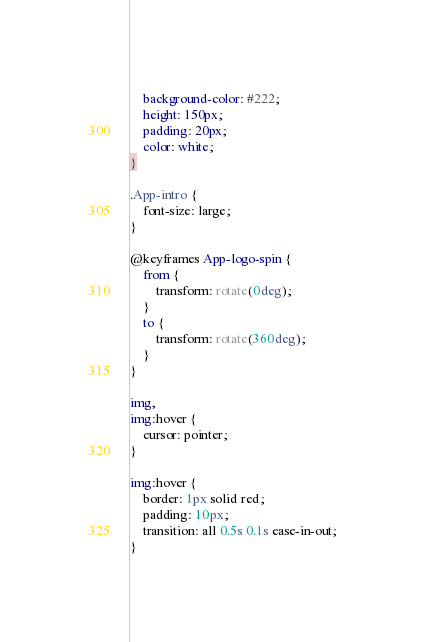Convert code to text. <code><loc_0><loc_0><loc_500><loc_500><_CSS_>    background-color: #222;
    height: 150px;
    padding: 20px;
    color: white;
}

.App-intro {
    font-size: large;
}

@keyframes App-logo-spin {
    from {
        transform: rotate(0deg);
    }
    to {
        transform: rotate(360deg);
    }
}

img,
img:hover {
    cursor: pointer;
}

img:hover {
    border: 1px solid red;
    padding: 10px;
    transition: all 0.5s 0.1s ease-in-out;
}</code> 